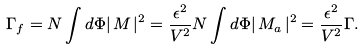Convert formula to latex. <formula><loc_0><loc_0><loc_500><loc_500>\Gamma _ { f } = N \int d \Phi | \, M \, | ^ { 2 } = \frac { \epsilon ^ { 2 } } { V ^ { 2 } } N \int d \Phi | \, M _ { a } \, | ^ { 2 } = \frac { \epsilon ^ { 2 } } { V ^ { 2 } } \Gamma .</formula> 